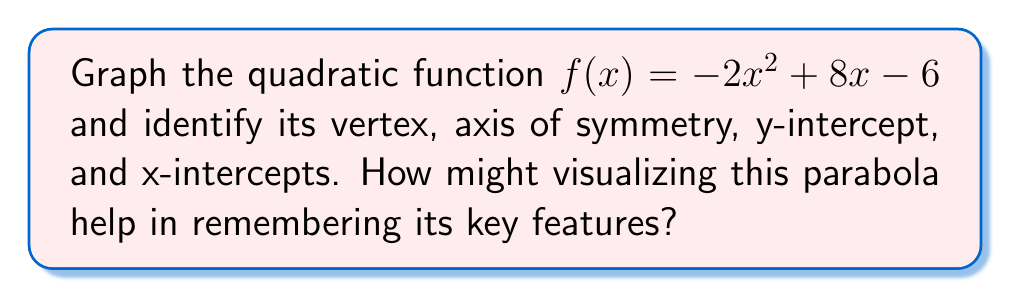What is the answer to this math problem? Let's approach this step-by-step:

1) First, let's find the vertex using the formula $x = -\frac{b}{2a}$:
   $x = -\frac{8}{2(-2)} = -\frac{8}{-4} = 2$
   
   To find y, we substitute x = 2 into the original function:
   $f(2) = -2(2)^2 + 8(2) - 6 = -8 + 16 - 6 = 2$
   
   So, the vertex is (2, 2).

2) The axis of symmetry is a vertical line that passes through the vertex. Its equation is $x = 2$.

3) To find the y-intercept, we set x = 0:
   $f(0) = -2(0)^2 + 8(0) - 6 = -6$
   The y-intercept is (0, -6).

4) To find x-intercepts, we set f(x) = 0 and solve:
   $-2x^2 + 8x - 6 = 0$
   $(2x - 6)(x - 1) = 0$
   $x = 3$ or $x = 1$
   The x-intercepts are (1, 0) and (3, 0).

5) Now we can graph the parabola:

[asy]
import graph;
size(200);
real f(real x) {return -2x^2+8x-6;}
xaxis("x");
yaxis("y");
draw(graph(f,-1,5));
dot((2,2));
dot((0,-6));
dot((1,0));
dot((3,0));
label("(2,2)",(2,2),NE);
label("(0,-6)",(0,-6),SW);
label("(1,0)",(1,0),S);
label("(3,0)",(3,0),S);
draw((2,-7)--(2,4),dashed);
label("x=2",(2,4),N);
[/asy]

Visualizing this parabola can help in remembering its key features by:
- The vertex (2, 2) is the highest point of the parabola, easy to spot visually.
- The axis of symmetry x = 2 divides the parabola into two mirror images.
- The y-intercept (0, -6) is where the parabola crosses the y-axis.
- The x-intercepts (1, 0) and (3, 0) are where the parabola crosses the x-axis.
- The parabola opens downward because a < 0 (-2 is negative).

This visual representation can enhance memory retention and understanding of quadratic functions.
Answer: Vertex: (2, 2); Axis of symmetry: x = 2; y-intercept: (0, -6); x-intercepts: (1, 0) and (3, 0) 